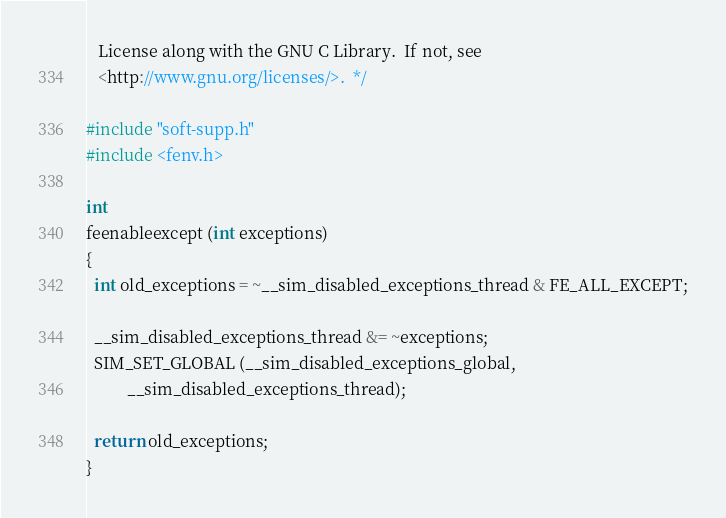Convert code to text. <code><loc_0><loc_0><loc_500><loc_500><_C_>   License along with the GNU C Library.  If not, see
   <http://www.gnu.org/licenses/>.  */

#include "soft-supp.h"
#include <fenv.h>

int
feenableexcept (int exceptions)
{
  int old_exceptions = ~__sim_disabled_exceptions_thread & FE_ALL_EXCEPT;

  __sim_disabled_exceptions_thread &= ~exceptions;
  SIM_SET_GLOBAL (__sim_disabled_exceptions_global,
		  __sim_disabled_exceptions_thread);

  return old_exceptions;
}
</code> 